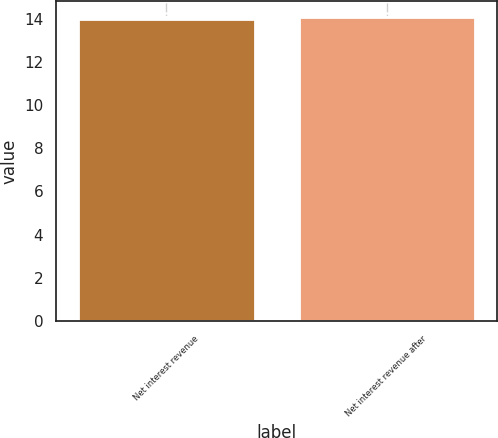Convert chart. <chart><loc_0><loc_0><loc_500><loc_500><bar_chart><fcel>Net interest revenue<fcel>Net interest revenue after<nl><fcel>14<fcel>14.1<nl></chart> 